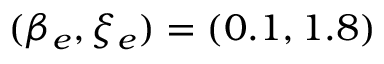Convert formula to latex. <formula><loc_0><loc_0><loc_500><loc_500>( \beta _ { e } , \xi _ { e } ) = ( 0 . 1 , 1 . 8 )</formula> 